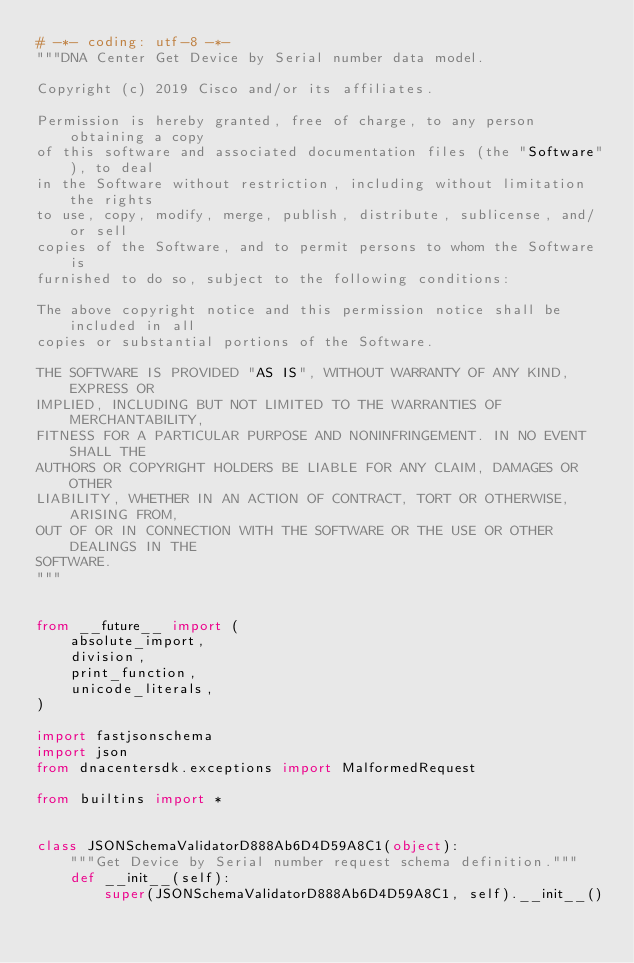<code> <loc_0><loc_0><loc_500><loc_500><_Python_># -*- coding: utf-8 -*-
"""DNA Center Get Device by Serial number data model.

Copyright (c) 2019 Cisco and/or its affiliates.

Permission is hereby granted, free of charge, to any person obtaining a copy
of this software and associated documentation files (the "Software"), to deal
in the Software without restriction, including without limitation the rights
to use, copy, modify, merge, publish, distribute, sublicense, and/or sell
copies of the Software, and to permit persons to whom the Software is
furnished to do so, subject to the following conditions:

The above copyright notice and this permission notice shall be included in all
copies or substantial portions of the Software.

THE SOFTWARE IS PROVIDED "AS IS", WITHOUT WARRANTY OF ANY KIND, EXPRESS OR
IMPLIED, INCLUDING BUT NOT LIMITED TO THE WARRANTIES OF MERCHANTABILITY,
FITNESS FOR A PARTICULAR PURPOSE AND NONINFRINGEMENT. IN NO EVENT SHALL THE
AUTHORS OR COPYRIGHT HOLDERS BE LIABLE FOR ANY CLAIM, DAMAGES OR OTHER
LIABILITY, WHETHER IN AN ACTION OF CONTRACT, TORT OR OTHERWISE, ARISING FROM,
OUT OF OR IN CONNECTION WITH THE SOFTWARE OR THE USE OR OTHER DEALINGS IN THE
SOFTWARE.
"""


from __future__ import (
    absolute_import,
    division,
    print_function,
    unicode_literals,
)

import fastjsonschema
import json
from dnacentersdk.exceptions import MalformedRequest

from builtins import *


class JSONSchemaValidatorD888Ab6D4D59A8C1(object):
    """Get Device by Serial number request schema definition."""
    def __init__(self):
        super(JSONSchemaValidatorD888Ab6D4D59A8C1, self).__init__()</code> 